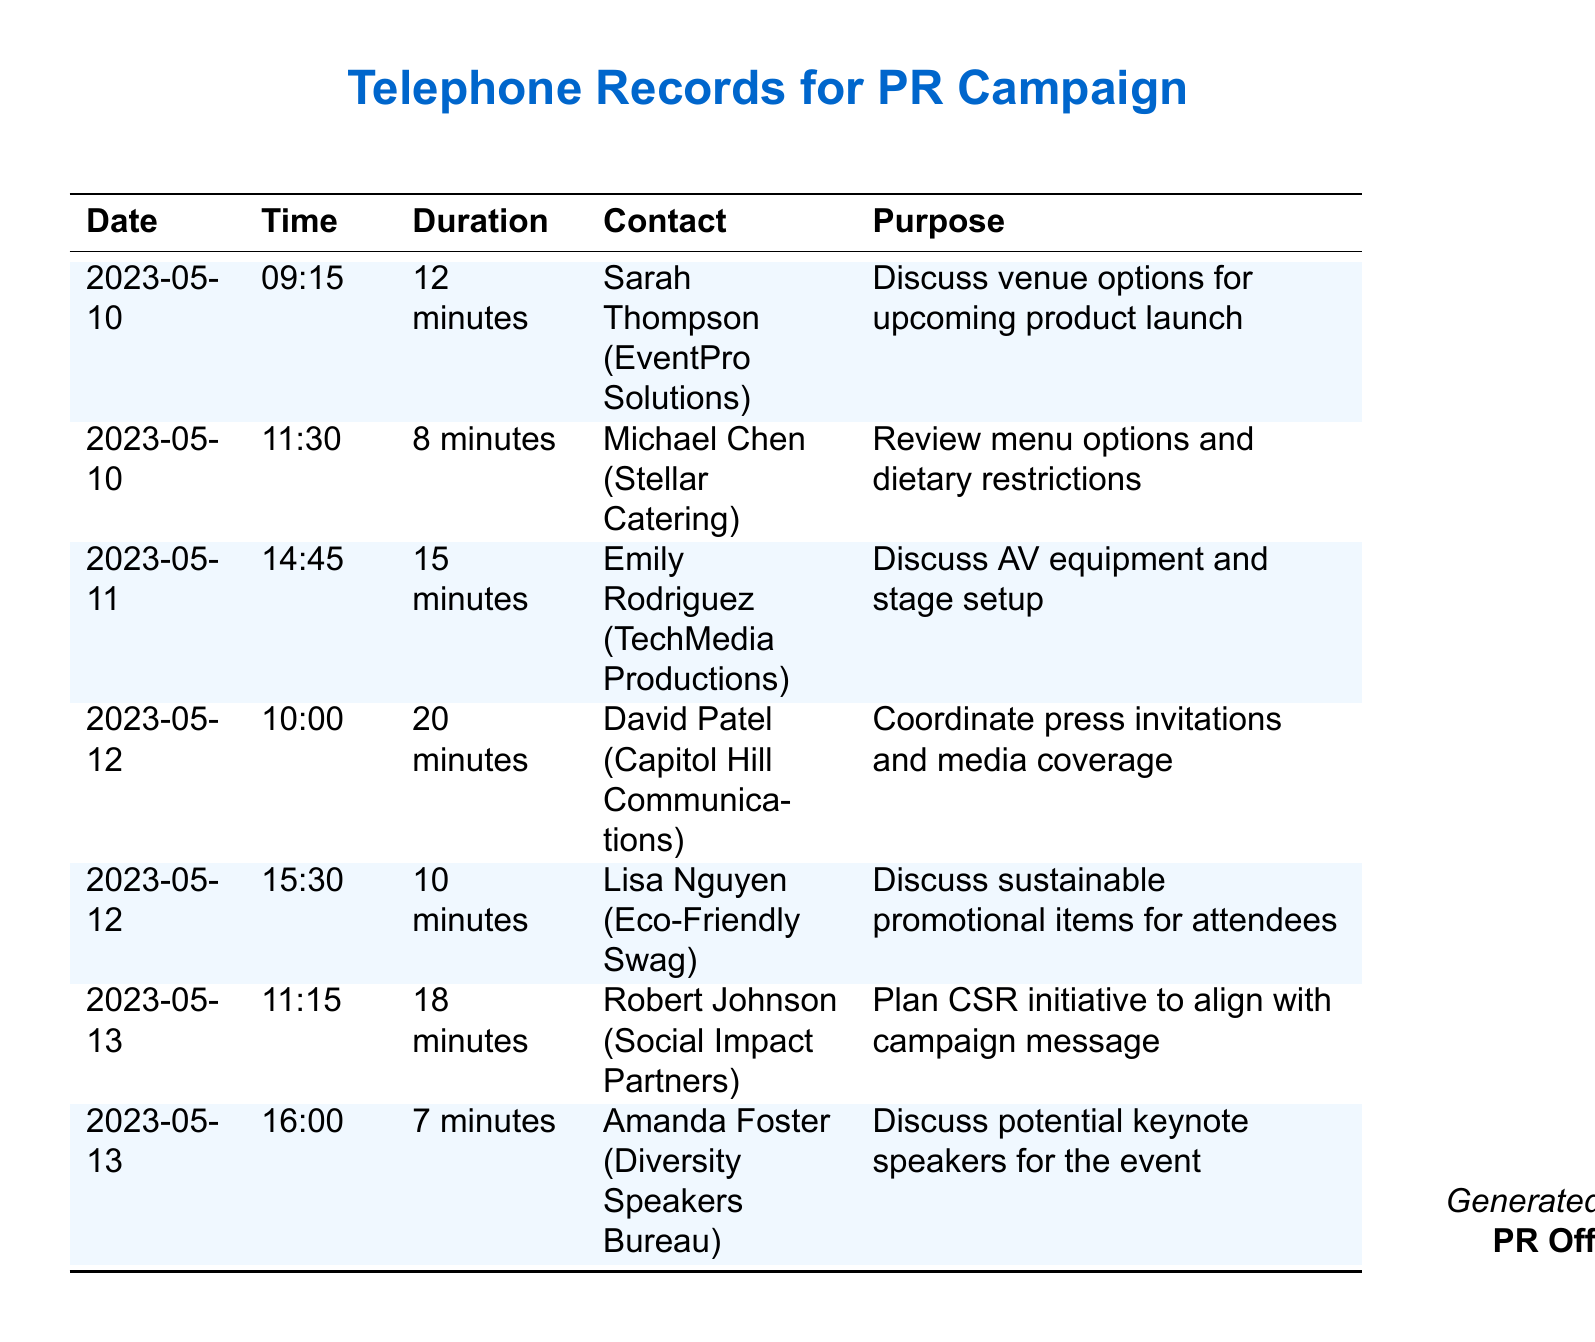What is the date of the call with Sarah Thompson? The date of the call with Sarah Thompson is mentioned in the document as 2023-05-10.
Answer: 2023-05-10 How long was the call with Michael Chen? The duration of the call with Michael Chen is specifically listed as 8 minutes in the records.
Answer: 8 minutes Who is the contact for sustainable promotional items? The contact for sustainable promotional items is named Lisa Nguyen according to the call details.
Answer: Lisa Nguyen How many minutes did the call with Emily Rodriguez last? The duration of the call with Emily Rodriguez, as noted, is 15 minutes.
Answer: 15 minutes What was the purpose of the call with David Patel? The purpose of the call with David Patel was to coordinate press invitations and media coverage.
Answer: Coordinate press invitations and media coverage Which vendor was discussed on May 13 related to CSR initiatives? The vendor discussed on May 13 related to CSR initiatives was Robert Johnson.
Answer: Robert Johnson How many calls were made on May 12? The number of calls made on May 12 is recorded as two.
Answer: Two What type of event is being organized according to the calls? The type being organized is a product launch, as discussed with Sarah Thompson.
Answer: Product launch Who was contacted for audio-visual equipment discussions? The contact for audio-visual equipment discussions is Emily Rodriguez.
Answer: Emily Rodriguez 